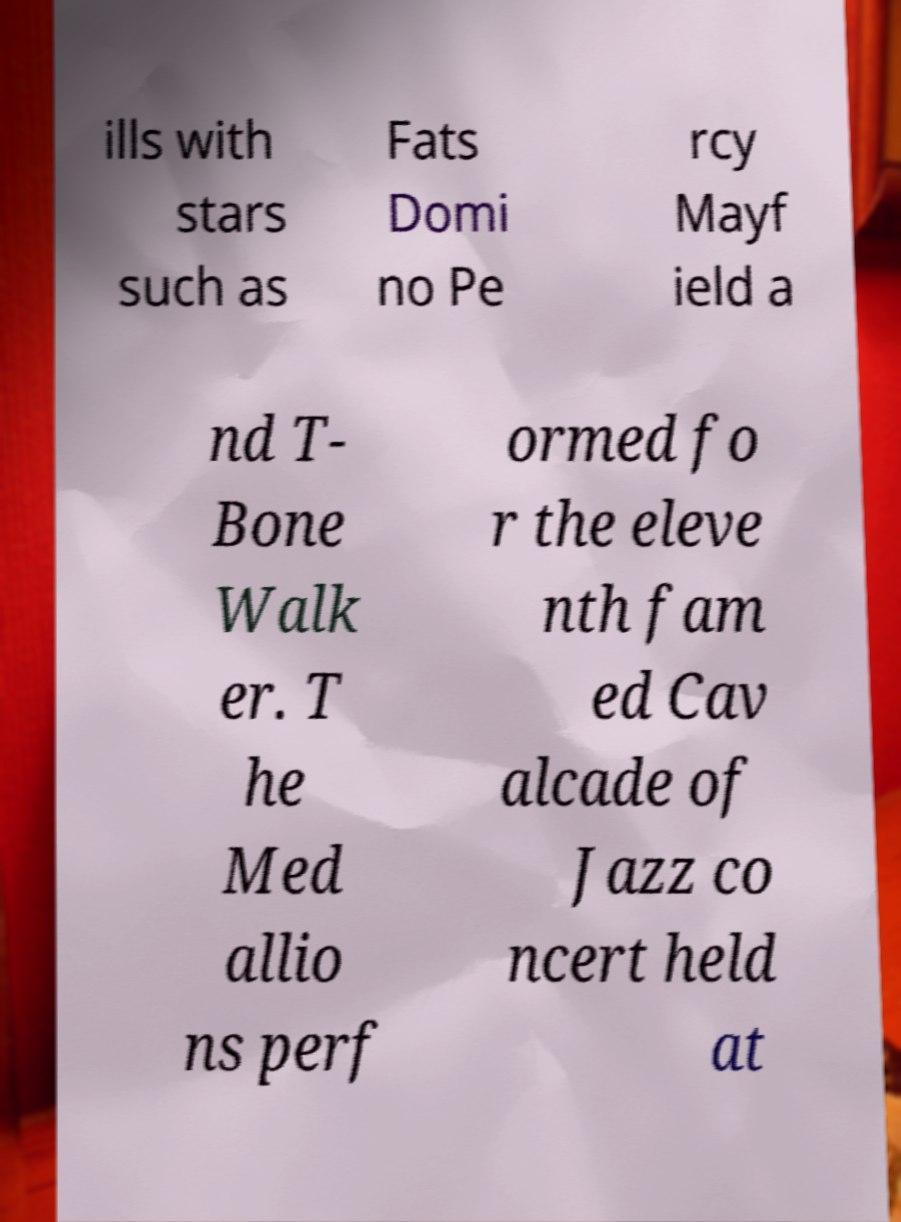What messages or text are displayed in this image? I need them in a readable, typed format. ills with stars such as Fats Domi no Pe rcy Mayf ield a nd T- Bone Walk er. T he Med allio ns perf ormed fo r the eleve nth fam ed Cav alcade of Jazz co ncert held at 